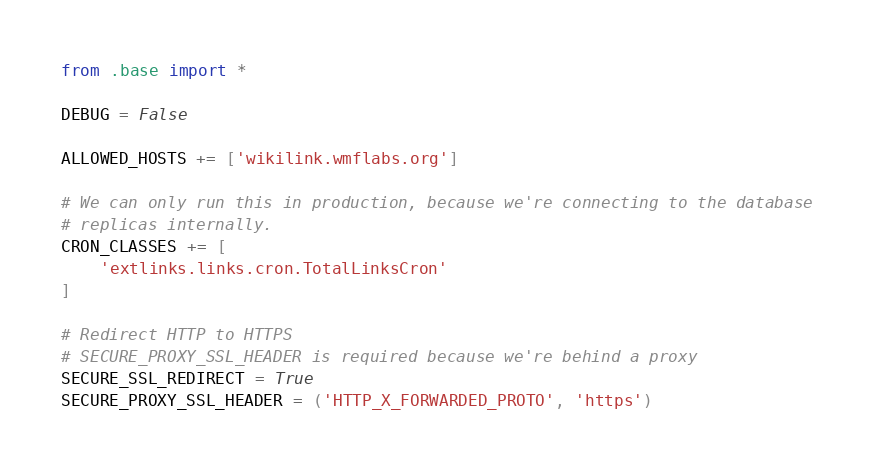Convert code to text. <code><loc_0><loc_0><loc_500><loc_500><_Python_>from .base import *

DEBUG = False

ALLOWED_HOSTS += ['wikilink.wmflabs.org']

# We can only run this in production, because we're connecting to the database
# replicas internally.
CRON_CLASSES += [
    'extlinks.links.cron.TotalLinksCron'
]

# Redirect HTTP to HTTPS
# SECURE_PROXY_SSL_HEADER is required because we're behind a proxy
SECURE_SSL_REDIRECT = True
SECURE_PROXY_SSL_HEADER = ('HTTP_X_FORWARDED_PROTO', 'https')
</code> 